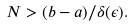<formula> <loc_0><loc_0><loc_500><loc_500>N > ( b - a ) / \delta ( \epsilon ) .</formula> 